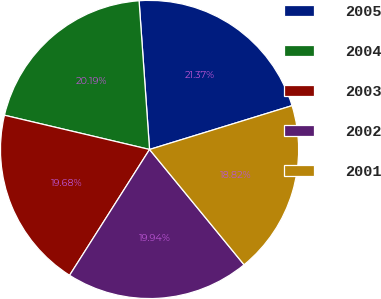Convert chart to OTSL. <chart><loc_0><loc_0><loc_500><loc_500><pie_chart><fcel>2005<fcel>2004<fcel>2003<fcel>2002<fcel>2001<nl><fcel>21.37%<fcel>20.19%<fcel>19.68%<fcel>19.94%<fcel>18.82%<nl></chart> 